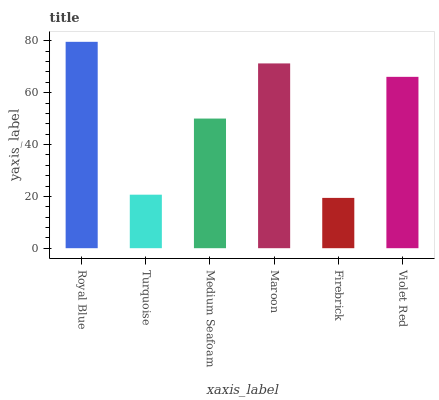Is Turquoise the minimum?
Answer yes or no. No. Is Turquoise the maximum?
Answer yes or no. No. Is Royal Blue greater than Turquoise?
Answer yes or no. Yes. Is Turquoise less than Royal Blue?
Answer yes or no. Yes. Is Turquoise greater than Royal Blue?
Answer yes or no. No. Is Royal Blue less than Turquoise?
Answer yes or no. No. Is Violet Red the high median?
Answer yes or no. Yes. Is Medium Seafoam the low median?
Answer yes or no. Yes. Is Maroon the high median?
Answer yes or no. No. Is Maroon the low median?
Answer yes or no. No. 